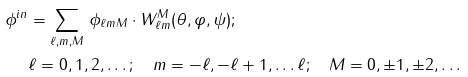<formula> <loc_0><loc_0><loc_500><loc_500>\phi ^ { i n } & = \sum _ { \ell , m , M } \, \phi _ { \ell m M } \cdot W _ { \ell m } ^ { M } ( \theta , \varphi , \psi ) ; \\ & \ell = 0 , 1 , 2 , \dots ; \quad m = - \ell , - \ell + 1 , \dots \ell ; \quad M = 0 , \pm 1 , \pm 2 , \dots \\</formula> 